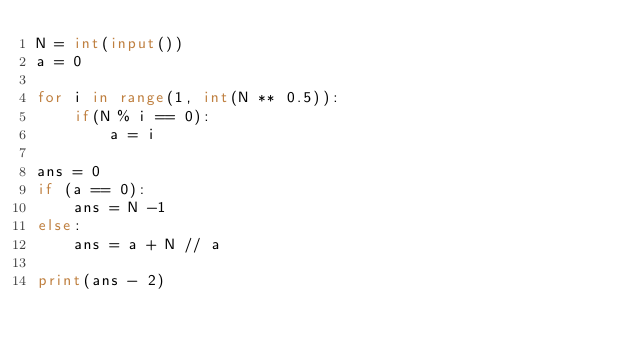<code> <loc_0><loc_0><loc_500><loc_500><_Python_>N = int(input())
a = 0

for i in range(1, int(N ** 0.5)):
    if(N % i == 0):
        a = i

ans = 0
if (a == 0):
    ans = N -1
else:
    ans = a + N // a

print(ans - 2)
</code> 